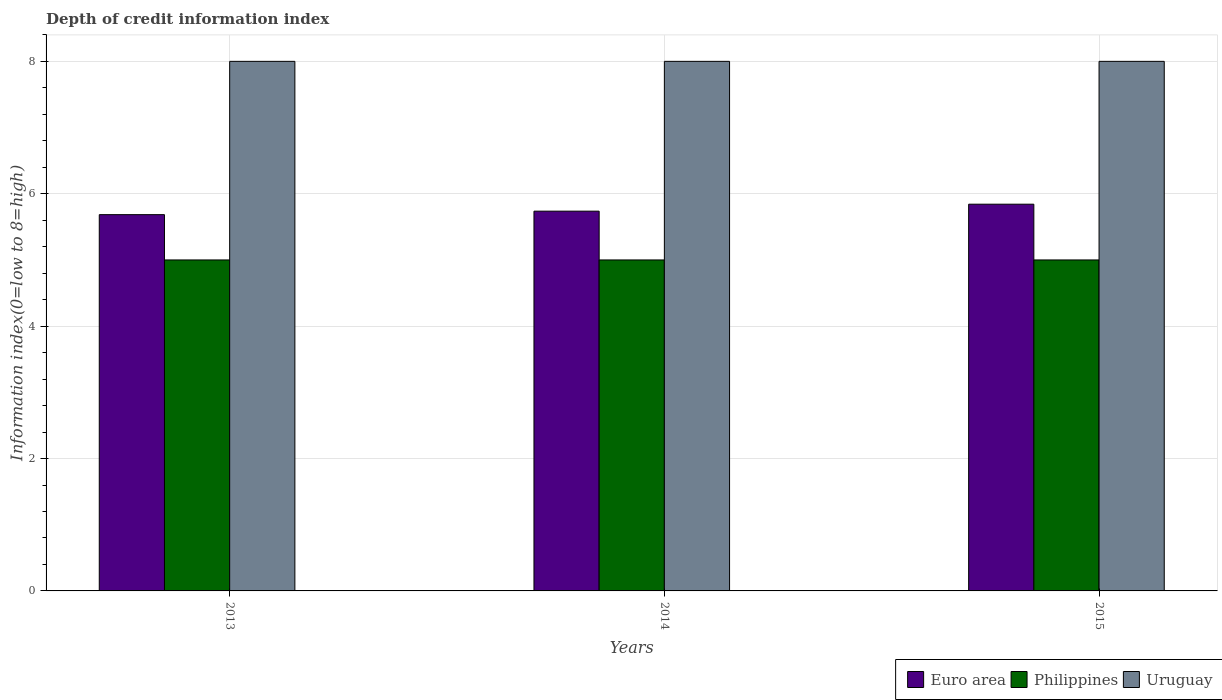How many different coloured bars are there?
Give a very brief answer. 3. Are the number of bars per tick equal to the number of legend labels?
Keep it short and to the point. Yes. What is the label of the 3rd group of bars from the left?
Provide a succinct answer. 2015. In how many cases, is the number of bars for a given year not equal to the number of legend labels?
Give a very brief answer. 0. What is the information index in Uruguay in 2014?
Offer a very short reply. 8. Across all years, what is the maximum information index in Uruguay?
Make the answer very short. 8. Across all years, what is the minimum information index in Euro area?
Give a very brief answer. 5.68. In which year was the information index in Euro area maximum?
Your response must be concise. 2015. In which year was the information index in Euro area minimum?
Provide a succinct answer. 2013. What is the total information index in Uruguay in the graph?
Offer a terse response. 24. What is the difference between the information index in Philippines in 2014 and the information index in Euro area in 2013?
Your answer should be very brief. -0.68. What is the average information index in Euro area per year?
Give a very brief answer. 5.75. In the year 2015, what is the difference between the information index in Uruguay and information index in Philippines?
Keep it short and to the point. 3. In how many years, is the information index in Uruguay greater than 5.6?
Ensure brevity in your answer.  3. Is the information index in Philippines in 2013 less than that in 2014?
Keep it short and to the point. No. Is the difference between the information index in Uruguay in 2013 and 2014 greater than the difference between the information index in Philippines in 2013 and 2014?
Make the answer very short. No. What is the difference between the highest and the second highest information index in Uruguay?
Provide a short and direct response. 0. What is the difference between the highest and the lowest information index in Philippines?
Your answer should be very brief. 0. Is the sum of the information index in Uruguay in 2013 and 2015 greater than the maximum information index in Philippines across all years?
Give a very brief answer. Yes. What does the 3rd bar from the left in 2015 represents?
Offer a terse response. Uruguay. What does the 1st bar from the right in 2013 represents?
Give a very brief answer. Uruguay. How many bars are there?
Your answer should be very brief. 9. Are the values on the major ticks of Y-axis written in scientific E-notation?
Ensure brevity in your answer.  No. How many legend labels are there?
Keep it short and to the point. 3. What is the title of the graph?
Your answer should be compact. Depth of credit information index. What is the label or title of the X-axis?
Your answer should be very brief. Years. What is the label or title of the Y-axis?
Your answer should be compact. Information index(0=low to 8=high). What is the Information index(0=low to 8=high) of Euro area in 2013?
Keep it short and to the point. 5.68. What is the Information index(0=low to 8=high) in Uruguay in 2013?
Your answer should be compact. 8. What is the Information index(0=low to 8=high) of Euro area in 2014?
Your answer should be very brief. 5.74. What is the Information index(0=low to 8=high) of Philippines in 2014?
Make the answer very short. 5. What is the Information index(0=low to 8=high) of Uruguay in 2014?
Your response must be concise. 8. What is the Information index(0=low to 8=high) in Euro area in 2015?
Your response must be concise. 5.84. Across all years, what is the maximum Information index(0=low to 8=high) in Euro area?
Make the answer very short. 5.84. Across all years, what is the minimum Information index(0=low to 8=high) in Euro area?
Offer a very short reply. 5.68. Across all years, what is the minimum Information index(0=low to 8=high) of Philippines?
Offer a terse response. 5. What is the total Information index(0=low to 8=high) in Euro area in the graph?
Your answer should be very brief. 17.26. What is the total Information index(0=low to 8=high) in Philippines in the graph?
Provide a succinct answer. 15. What is the total Information index(0=low to 8=high) in Uruguay in the graph?
Give a very brief answer. 24. What is the difference between the Information index(0=low to 8=high) of Euro area in 2013 and that in 2014?
Provide a succinct answer. -0.05. What is the difference between the Information index(0=low to 8=high) of Philippines in 2013 and that in 2014?
Ensure brevity in your answer.  0. What is the difference between the Information index(0=low to 8=high) of Euro area in 2013 and that in 2015?
Offer a very short reply. -0.16. What is the difference between the Information index(0=low to 8=high) in Euro area in 2014 and that in 2015?
Provide a short and direct response. -0.11. What is the difference between the Information index(0=low to 8=high) of Philippines in 2014 and that in 2015?
Your answer should be compact. 0. What is the difference between the Information index(0=low to 8=high) of Uruguay in 2014 and that in 2015?
Make the answer very short. 0. What is the difference between the Information index(0=low to 8=high) in Euro area in 2013 and the Information index(0=low to 8=high) in Philippines in 2014?
Offer a very short reply. 0.68. What is the difference between the Information index(0=low to 8=high) in Euro area in 2013 and the Information index(0=low to 8=high) in Uruguay in 2014?
Keep it short and to the point. -2.32. What is the difference between the Information index(0=low to 8=high) in Philippines in 2013 and the Information index(0=low to 8=high) in Uruguay in 2014?
Provide a short and direct response. -3. What is the difference between the Information index(0=low to 8=high) of Euro area in 2013 and the Information index(0=low to 8=high) of Philippines in 2015?
Ensure brevity in your answer.  0.68. What is the difference between the Information index(0=low to 8=high) in Euro area in 2013 and the Information index(0=low to 8=high) in Uruguay in 2015?
Offer a terse response. -2.32. What is the difference between the Information index(0=low to 8=high) of Philippines in 2013 and the Information index(0=low to 8=high) of Uruguay in 2015?
Offer a very short reply. -3. What is the difference between the Information index(0=low to 8=high) of Euro area in 2014 and the Information index(0=low to 8=high) of Philippines in 2015?
Offer a terse response. 0.74. What is the difference between the Information index(0=low to 8=high) in Euro area in 2014 and the Information index(0=low to 8=high) in Uruguay in 2015?
Make the answer very short. -2.26. What is the average Information index(0=low to 8=high) in Euro area per year?
Your answer should be very brief. 5.75. What is the average Information index(0=low to 8=high) of Uruguay per year?
Ensure brevity in your answer.  8. In the year 2013, what is the difference between the Information index(0=low to 8=high) of Euro area and Information index(0=low to 8=high) of Philippines?
Ensure brevity in your answer.  0.68. In the year 2013, what is the difference between the Information index(0=low to 8=high) of Euro area and Information index(0=low to 8=high) of Uruguay?
Your answer should be compact. -2.32. In the year 2014, what is the difference between the Information index(0=low to 8=high) of Euro area and Information index(0=low to 8=high) of Philippines?
Provide a succinct answer. 0.74. In the year 2014, what is the difference between the Information index(0=low to 8=high) in Euro area and Information index(0=low to 8=high) in Uruguay?
Keep it short and to the point. -2.26. In the year 2015, what is the difference between the Information index(0=low to 8=high) in Euro area and Information index(0=low to 8=high) in Philippines?
Your answer should be very brief. 0.84. In the year 2015, what is the difference between the Information index(0=low to 8=high) in Euro area and Information index(0=low to 8=high) in Uruguay?
Offer a very short reply. -2.16. In the year 2015, what is the difference between the Information index(0=low to 8=high) in Philippines and Information index(0=low to 8=high) in Uruguay?
Offer a terse response. -3. What is the ratio of the Information index(0=low to 8=high) of Euro area in 2013 to that in 2014?
Offer a terse response. 0.99. What is the ratio of the Information index(0=low to 8=high) of Uruguay in 2013 to that in 2014?
Provide a succinct answer. 1. What is the ratio of the Information index(0=low to 8=high) of Euro area in 2013 to that in 2015?
Provide a short and direct response. 0.97. What is the ratio of the Information index(0=low to 8=high) of Euro area in 2014 to that in 2015?
Your answer should be very brief. 0.98. What is the ratio of the Information index(0=low to 8=high) of Uruguay in 2014 to that in 2015?
Your answer should be compact. 1. What is the difference between the highest and the second highest Information index(0=low to 8=high) of Euro area?
Provide a succinct answer. 0.11. What is the difference between the highest and the second highest Information index(0=low to 8=high) in Uruguay?
Ensure brevity in your answer.  0. What is the difference between the highest and the lowest Information index(0=low to 8=high) in Euro area?
Your answer should be compact. 0.16. What is the difference between the highest and the lowest Information index(0=low to 8=high) in Philippines?
Your response must be concise. 0. 